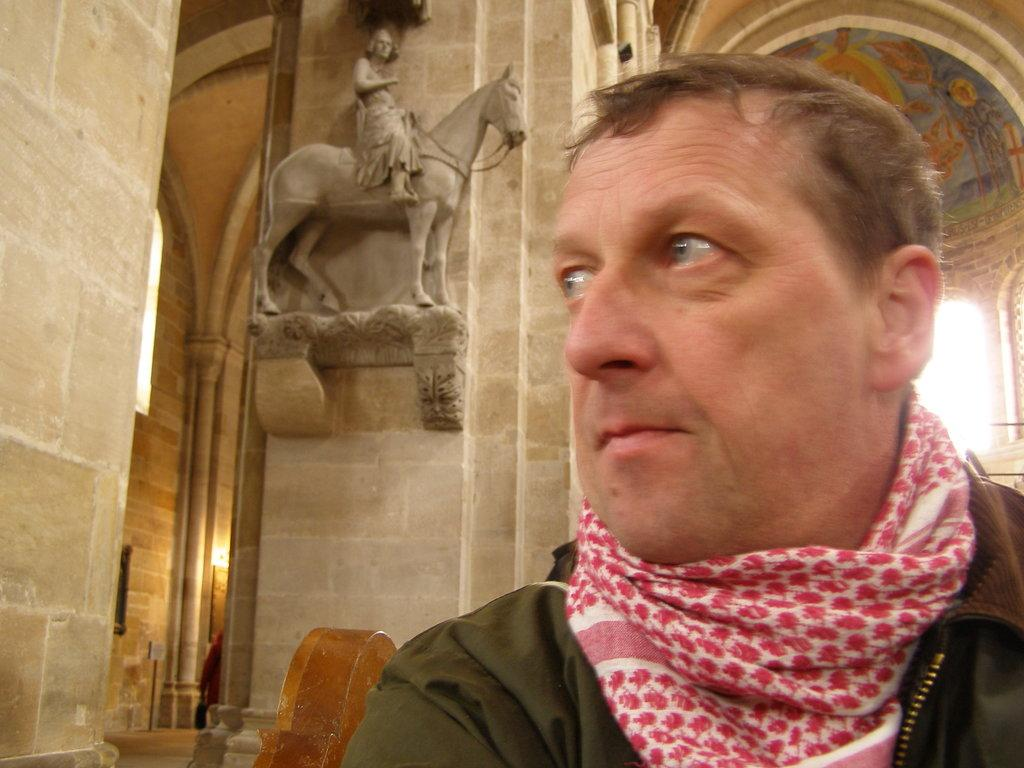Who is present in the image? There is a man in the image. What direction is the man looking in? The man is looking to the right side. What other object can be seen in the image? There is a statue in the image. What is the statue depicting? The statue depicts a person sitting on a horse. What type of chalk is being used to draw on the glass in the image? There is no chalk or glass present in the image; it features a man looking at a statue. 